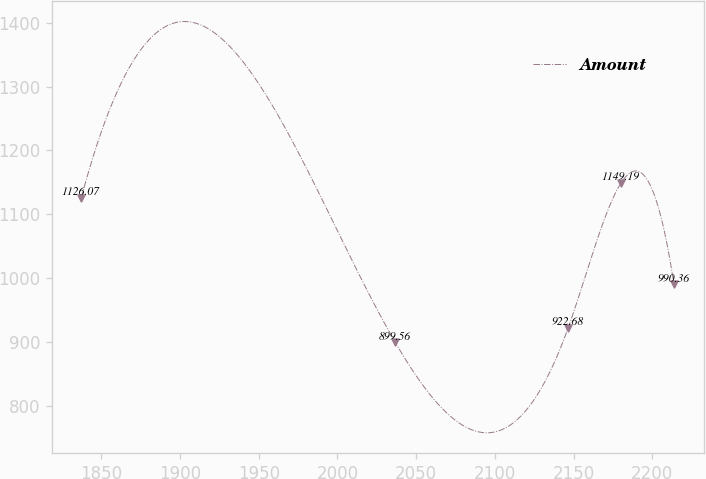<chart> <loc_0><loc_0><loc_500><loc_500><line_chart><ecel><fcel>Amount<nl><fcel>1837.25<fcel>1126.07<nl><fcel>2036.7<fcel>899.56<nl><fcel>2146.64<fcel>922.68<nl><fcel>2180.21<fcel>1149.19<nl><fcel>2213.78<fcel>990.36<nl></chart> 